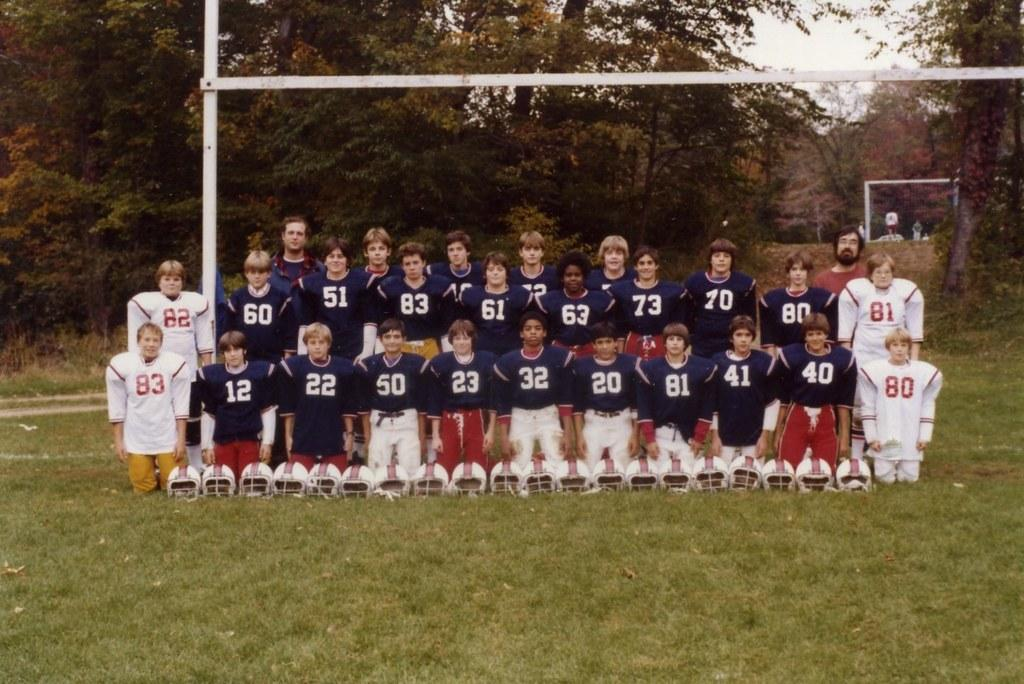<image>
Give a short and clear explanation of the subsequent image. The young players on a pee-wee football team wear uniforms with the numbers 40, 80, 22 and 12, among many others. 